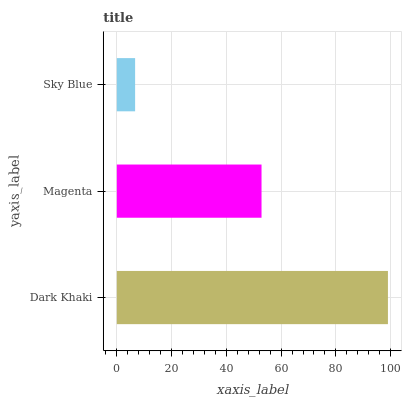Is Sky Blue the minimum?
Answer yes or no. Yes. Is Dark Khaki the maximum?
Answer yes or no. Yes. Is Magenta the minimum?
Answer yes or no. No. Is Magenta the maximum?
Answer yes or no. No. Is Dark Khaki greater than Magenta?
Answer yes or no. Yes. Is Magenta less than Dark Khaki?
Answer yes or no. Yes. Is Magenta greater than Dark Khaki?
Answer yes or no. No. Is Dark Khaki less than Magenta?
Answer yes or no. No. Is Magenta the high median?
Answer yes or no. Yes. Is Magenta the low median?
Answer yes or no. Yes. Is Dark Khaki the high median?
Answer yes or no. No. Is Dark Khaki the low median?
Answer yes or no. No. 